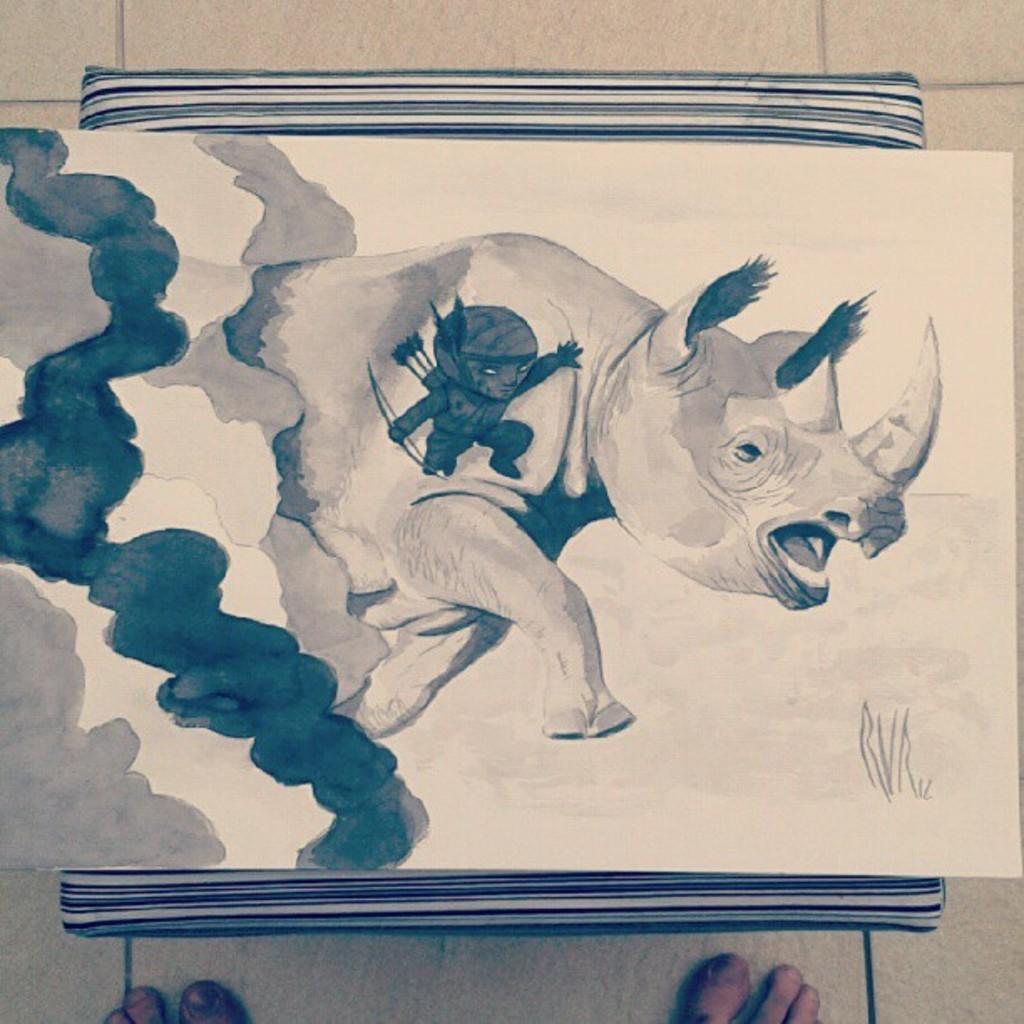What is depicted on the paper in the image? The paper has a drawing of a rhinoceros and a person. What is the paper placed on in the image? There is an object with the paper on it. Can you describe the legs visible at the bottom of the object? The legs of a person are visible at the bottom of the object. How many boys are wearing socks in the image? There are no boys or socks present in the image. Can you describe the toes of the person in the drawing on the paper? The image does not show the toes of the person in the drawing; it only depicts the person's legs. 